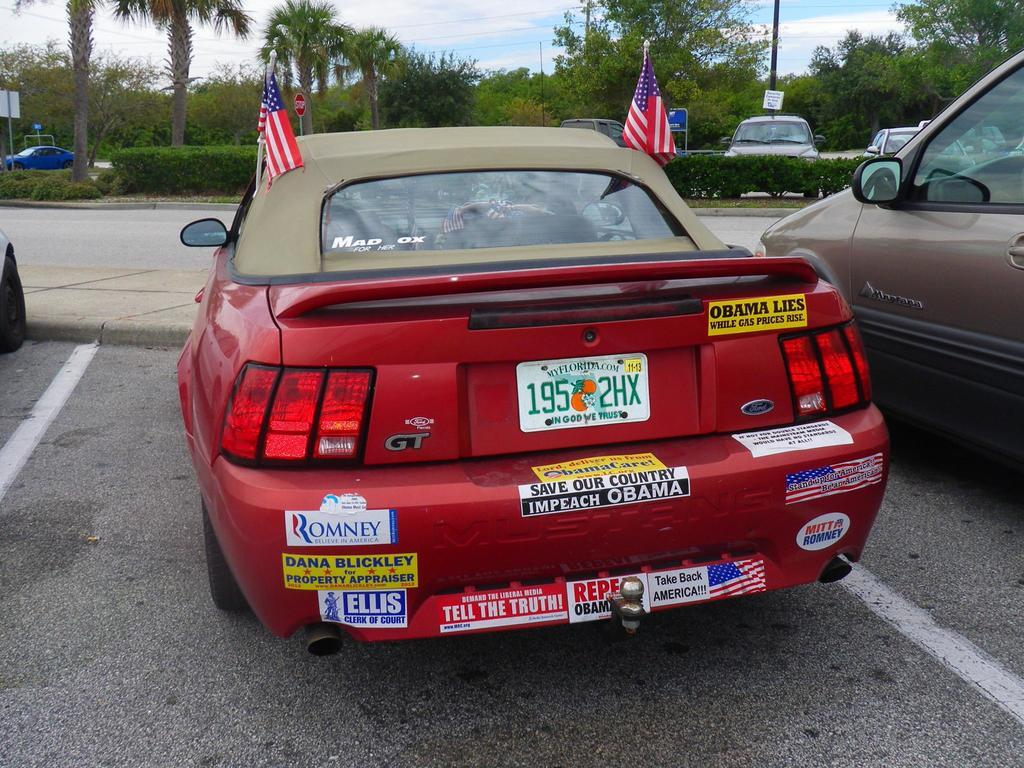What type of vehicles can be seen in the image? There are cars in the image. What additional objects are present in the image? There are flags, a road, plants, poles, boards, trees, and the sky is visible in the background with clouds. What might be used for displaying information or advertisements in the image? The boards in the image might be used for displaying information or advertisements. What type of natural elements are present in the image? Plants and trees are the natural elements present in the image. What is the position of the person expressing anger in the image? There is no person expressing anger in the image. What type of voyage is depicted in the image? There is no voyage depicted in the image; it features cars, flags, a road, plants, poles, boards, trees, and the sky with clouds. 